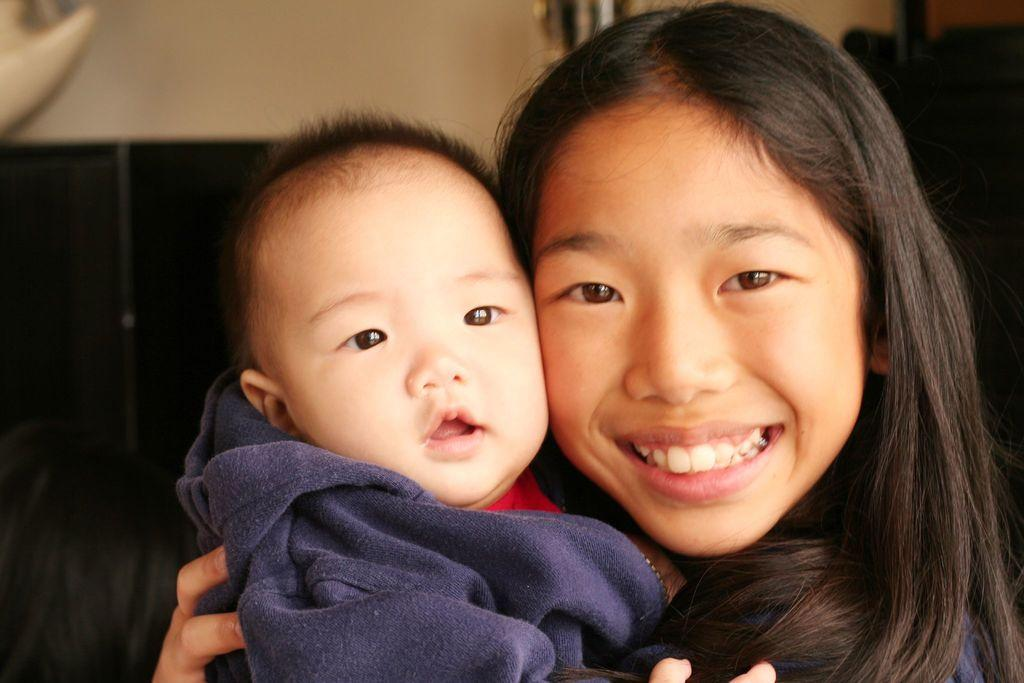Who is the main subject in the image? There is a girl in the image. What is the girl doing in the image? The girl is holding a baby in her hands. What is the girl's expression in the image? The girl is smiling. What type of knowledge is the girl sharing with the baby in the image? There is no indication in the image that the girl is sharing any knowledge with the baby. 